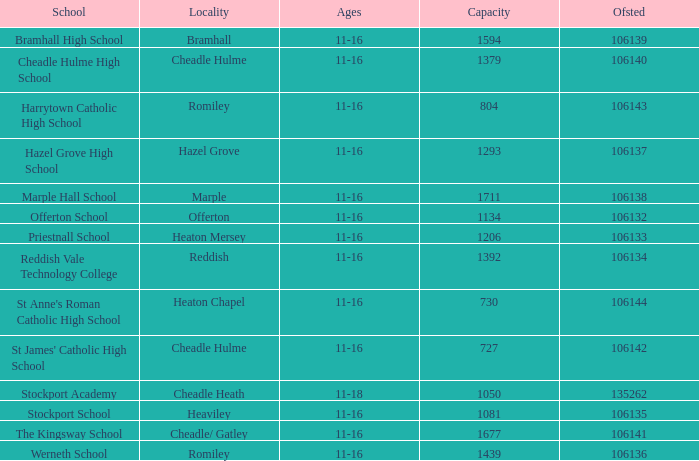I'm looking to parse the entire table for insights. Could you assist me with that? {'header': ['School', 'Locality', 'Ages', 'Capacity', 'Ofsted'], 'rows': [['Bramhall High School', 'Bramhall', '11-16', '1594', '106139'], ['Cheadle Hulme High School', 'Cheadle Hulme', '11-16', '1379', '106140'], ['Harrytown Catholic High School', 'Romiley', '11-16', '804', '106143'], ['Hazel Grove High School', 'Hazel Grove', '11-16', '1293', '106137'], ['Marple Hall School', 'Marple', '11-16', '1711', '106138'], ['Offerton School', 'Offerton', '11-16', '1134', '106132'], ['Priestnall School', 'Heaton Mersey', '11-16', '1206', '106133'], ['Reddish Vale Technology College', 'Reddish', '11-16', '1392', '106134'], ["St Anne's Roman Catholic High School", 'Heaton Chapel', '11-16', '730', '106144'], ["St James' Catholic High School", 'Cheadle Hulme', '11-16', '727', '106142'], ['Stockport Academy', 'Cheadle Heath', '11-18', '1050', '135262'], ['Stockport School', 'Heaviley', '11-16', '1081', '106135'], ['The Kingsway School', 'Cheadle/ Gatley', '11-16', '1677', '106141'], ['Werneth School', 'Romiley', '11-16', '1439', '106136']]} What is heaton chapel's volume? 730.0. 